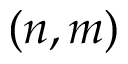<formula> <loc_0><loc_0><loc_500><loc_500>( n , m )</formula> 